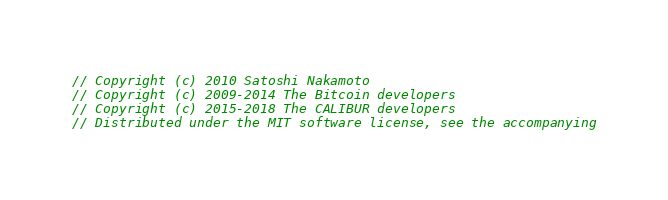Convert code to text. <code><loc_0><loc_0><loc_500><loc_500><_C_>// Copyright (c) 2010 Satoshi Nakamoto
// Copyright (c) 2009-2014 The Bitcoin developers
// Copyright (c) 2015-2018 The CALIBUR developers
// Distributed under the MIT software license, see the accompanying</code> 